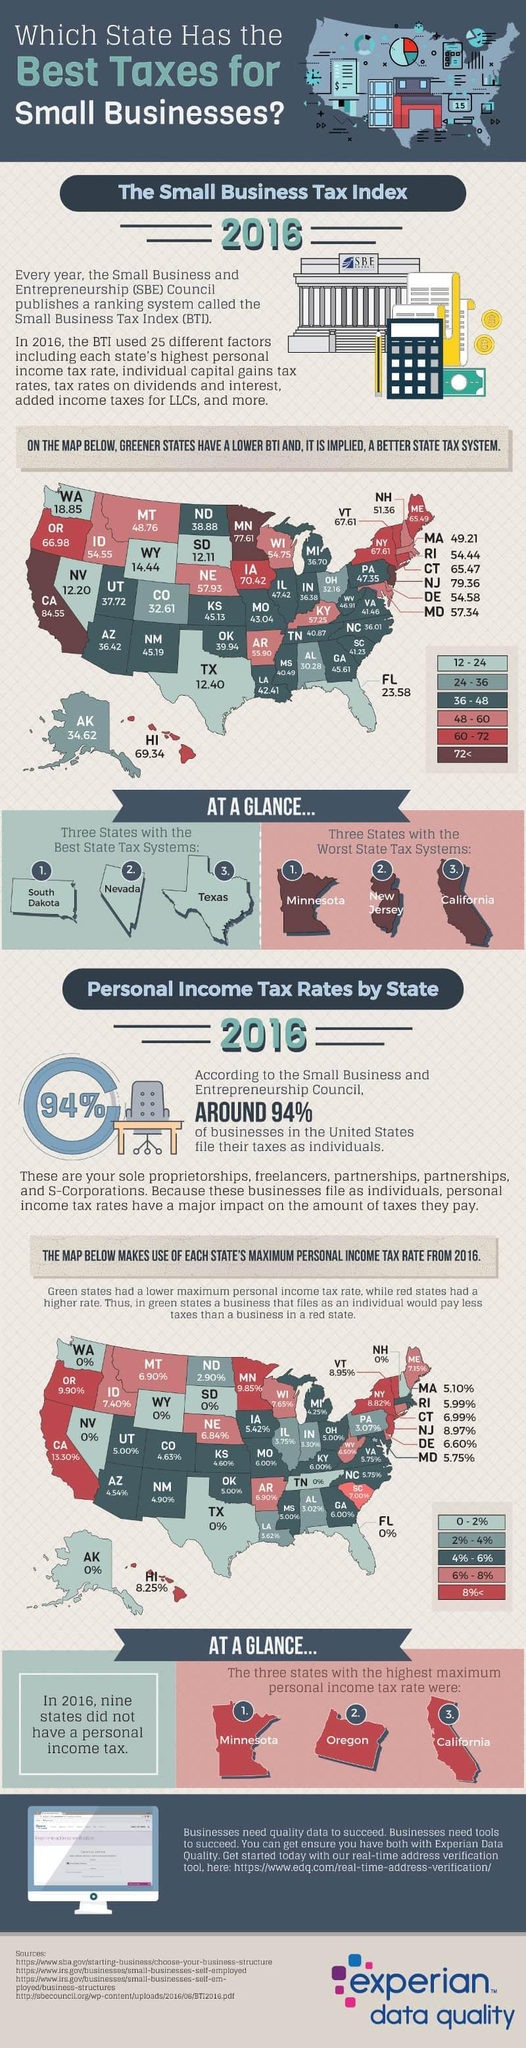What is the maximum personal income tax rate in New Mexico in 2016?
Answer the question with a short phrase. 4.90% Which state in the Western United States has the highest Business Tax Index in 2016? CA Which U.S. state has the the worst state tax system in 2016 other than Minnesota & New Jersey? California How many states are there in the western region of the U.S.? 13 What is the Business Tax Index of Alaska in 2016? 34.62 What is the maximum personal income tax rate in Hawaii in 2016? 8.25% What is the Business Tax Index of Texas in 2016? 12.40 Which U.S. state has the the best state tax system in 2016 other than South Dakota & Texas? Nevada 